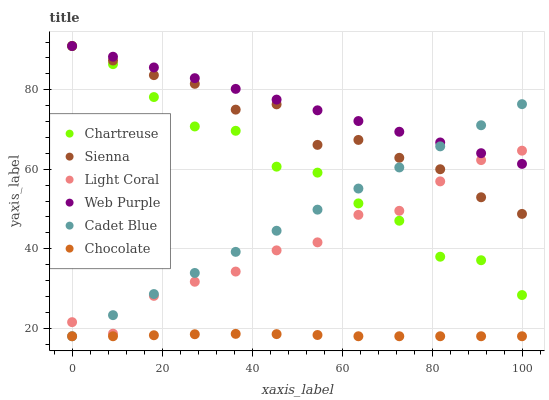Does Chocolate have the minimum area under the curve?
Answer yes or no. Yes. Does Web Purple have the maximum area under the curve?
Answer yes or no. Yes. Does Cadet Blue have the minimum area under the curve?
Answer yes or no. No. Does Cadet Blue have the maximum area under the curve?
Answer yes or no. No. Is Web Purple the smoothest?
Answer yes or no. Yes. Is Chartreuse the roughest?
Answer yes or no. Yes. Is Cadet Blue the smoothest?
Answer yes or no. No. Is Cadet Blue the roughest?
Answer yes or no. No. Does Cadet Blue have the lowest value?
Answer yes or no. Yes. Does Web Purple have the lowest value?
Answer yes or no. No. Does Chartreuse have the highest value?
Answer yes or no. Yes. Does Cadet Blue have the highest value?
Answer yes or no. No. Is Chocolate less than Chartreuse?
Answer yes or no. Yes. Is Light Coral greater than Chocolate?
Answer yes or no. Yes. Does Cadet Blue intersect Web Purple?
Answer yes or no. Yes. Is Cadet Blue less than Web Purple?
Answer yes or no. No. Is Cadet Blue greater than Web Purple?
Answer yes or no. No. Does Chocolate intersect Chartreuse?
Answer yes or no. No. 